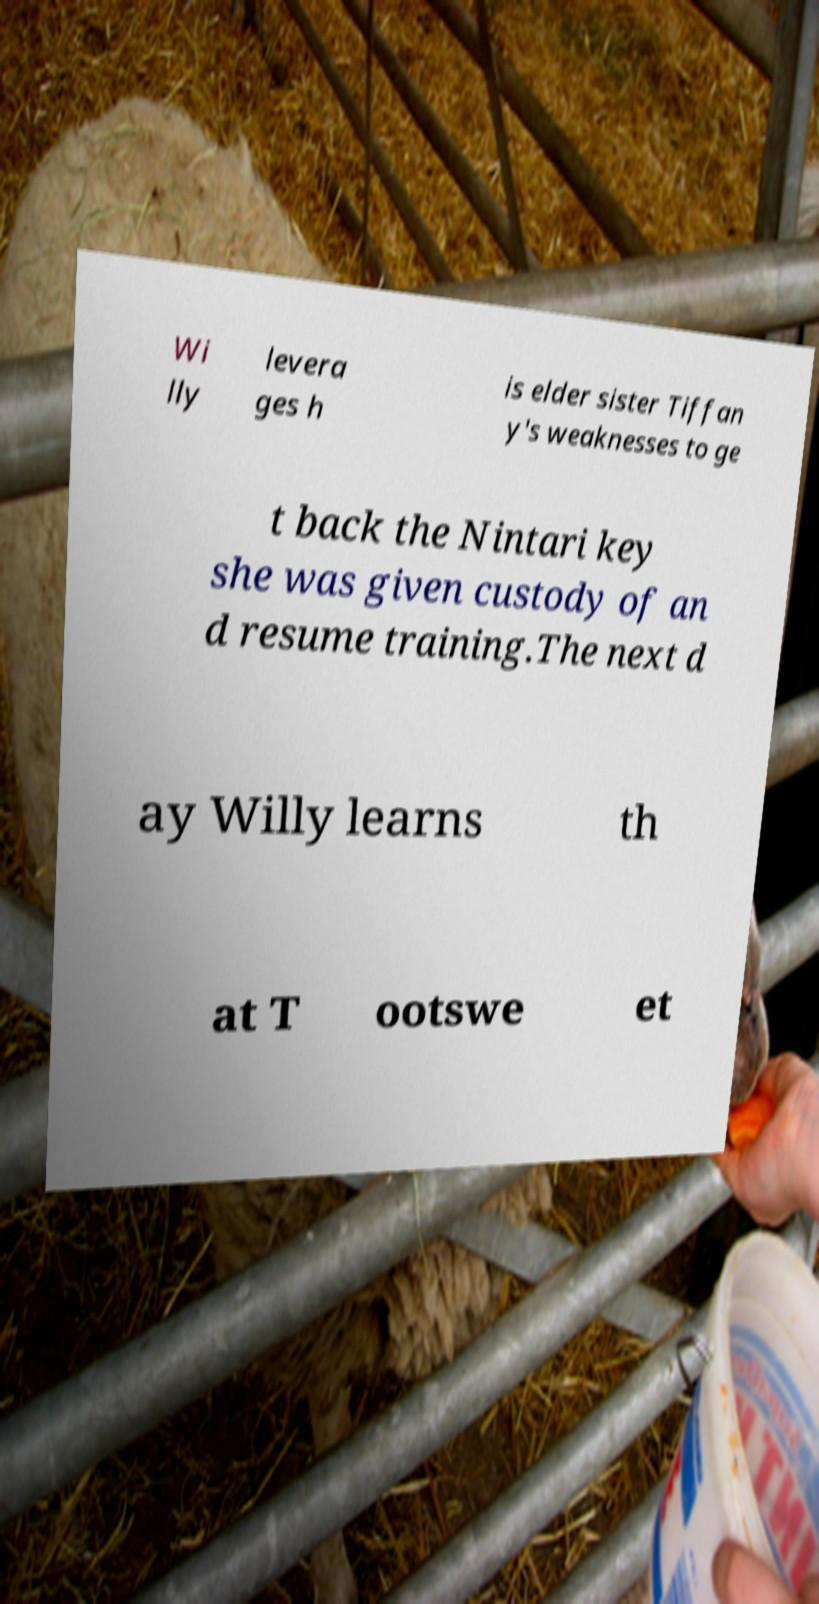There's text embedded in this image that I need extracted. Can you transcribe it verbatim? Wi lly levera ges h is elder sister Tiffan y's weaknesses to ge t back the Nintari key she was given custody of an d resume training.The next d ay Willy learns th at T ootswe et 